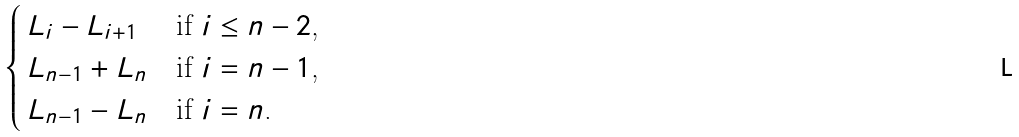<formula> <loc_0><loc_0><loc_500><loc_500>\begin{cases} \, L _ { i } - L _ { i + 1 } & \text {if $i \leq n-2$,} \\ \, L _ { n - 1 } + L _ { n } & \text {if $i=n-1$,} \\ \, L _ { n - 1 } - L _ { n } & \text {if $i=n$.} \end{cases}</formula> 